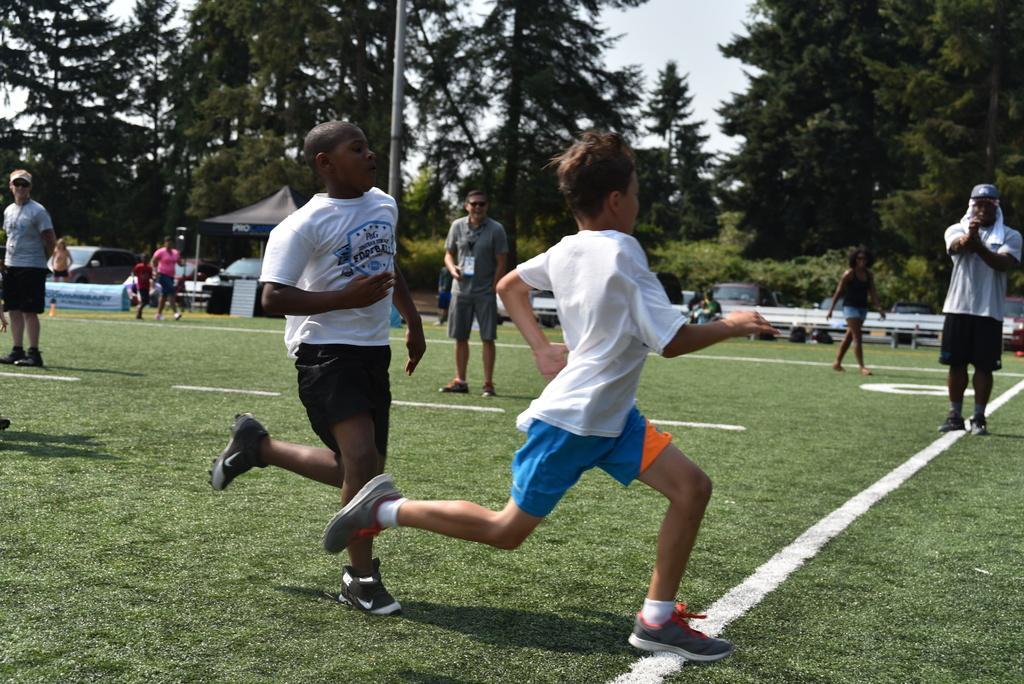Describe this image in one or two sentences. In this picture I can see couple of boys are running and few are walking and few are standing and I can see trees and a tent and few cars parked in the back and I can see grass on the ground and a pole and I can see cloudy sky. 